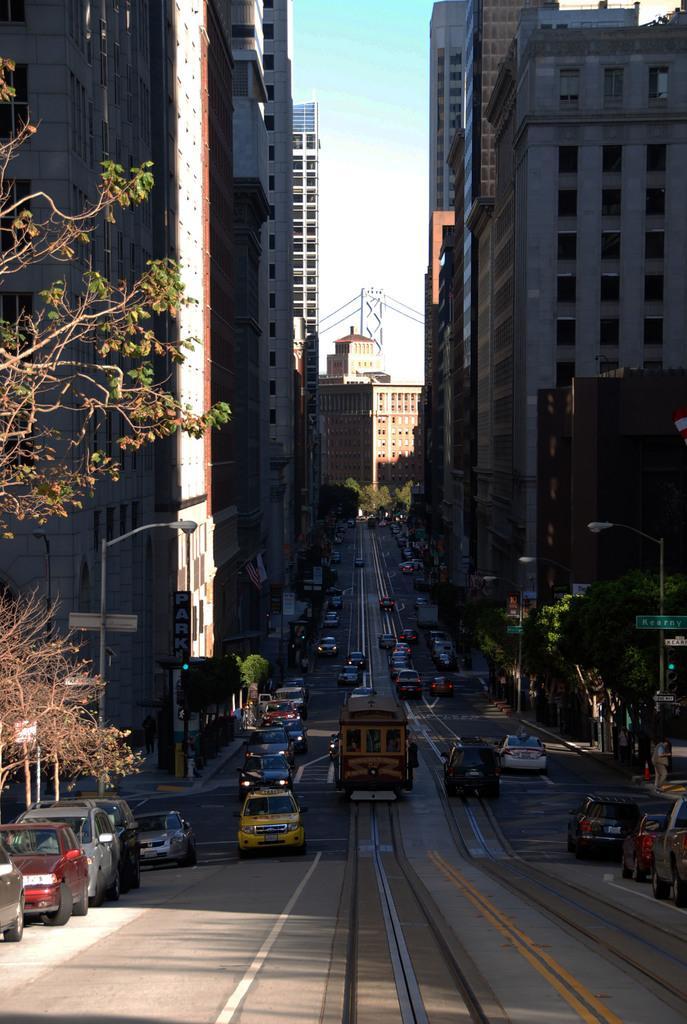Can you describe this image briefly? This picture is clicked outside. In the center we can see the vehicles seems to be running on the road and we can see the trees, buildings, text on the boards, lampposts and some other items. In the background we can see the sky, metal rods, buildings and trees. 